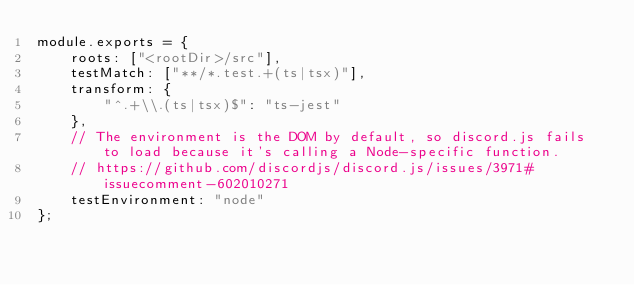Convert code to text. <code><loc_0><loc_0><loc_500><loc_500><_JavaScript_>module.exports = {
    roots: ["<rootDir>/src"],
    testMatch: ["**/*.test.+(ts|tsx)"],
    transform: {
        "^.+\\.(ts|tsx)$": "ts-jest"
    },
    // The environment is the DOM by default, so discord.js fails to load because it's calling a Node-specific function.
    // https://github.com/discordjs/discord.js/issues/3971#issuecomment-602010271
    testEnvironment: "node"
};
</code> 